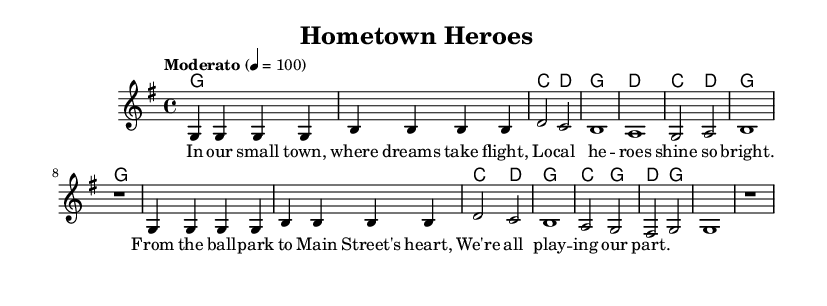What is the key signature of this music? The key signature is G major, indicated by one sharp (F#) in the music.
Answer: G major What is the time signature of the piece? The time signature is 4/4, which is indicated at the beginning of the score. It shows that there are four beats in each measure, and the quarter note gets one beat.
Answer: 4/4 What is the tempo marking for the piece? The tempo marking is "Moderato," which typically suggests a moderate pace. The metronome marking is indicated as 4 = 100.
Answer: Moderato How many measures are there in the melody? There are 8 measures in the melody, as each line of the melody consists of 4 measures and there are two lines.
Answer: 8 What is the first lyric line of the song? The first lyric line is "In our small town, where dreams take flight," which is indicated in the lyric mode under the melody of the score.
Answer: In our small town, where dreams take flight What chord is played in the second measure of the harmonies? The second measure of harmonies shows the chord G, which is played throughout the measure.
Answer: G What local hero-related theme does the song convey? The song celebrates local heroes by emphasizing community spirit and participation in activities like baseball and local events, as depicted in the lyrics.
Answer: Community spirit 